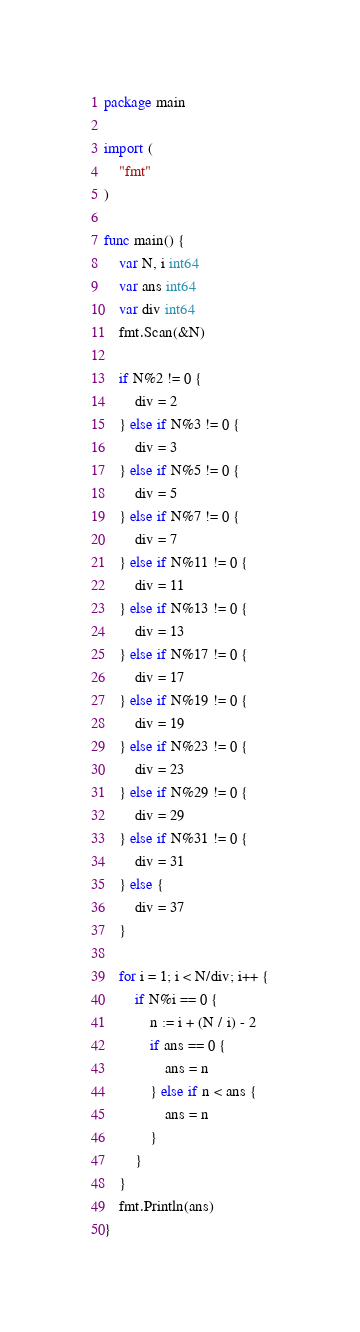<code> <loc_0><loc_0><loc_500><loc_500><_Go_>package main

import (
	"fmt"
)

func main() {
	var N, i int64
	var ans int64
	var div int64
	fmt.Scan(&N)

	if N%2 != 0 {
		div = 2
	} else if N%3 != 0 {
		div = 3
	} else if N%5 != 0 {
		div = 5
	} else if N%7 != 0 {
		div = 7
	} else if N%11 != 0 {
		div = 11
	} else if N%13 != 0 {
		div = 13
	} else if N%17 != 0 {
		div = 17
	} else if N%19 != 0 {
		div = 19
	} else if N%23 != 0 {
		div = 23
	} else if N%29 != 0 {
		div = 29
	} else if N%31 != 0 {
		div = 31
	} else {
		div = 37
	}

	for i = 1; i < N/div; i++ {
		if N%i == 0 {
			n := i + (N / i) - 2
			if ans == 0 {
				ans = n
			} else if n < ans {
				ans = n
			}
		}
	}
	fmt.Println(ans)
}
</code> 